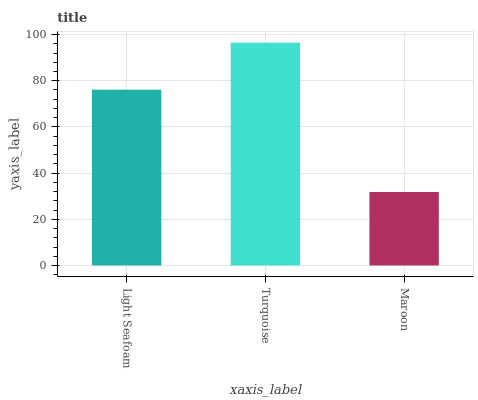Is Maroon the minimum?
Answer yes or no. Yes. Is Turquoise the maximum?
Answer yes or no. Yes. Is Turquoise the minimum?
Answer yes or no. No. Is Maroon the maximum?
Answer yes or no. No. Is Turquoise greater than Maroon?
Answer yes or no. Yes. Is Maroon less than Turquoise?
Answer yes or no. Yes. Is Maroon greater than Turquoise?
Answer yes or no. No. Is Turquoise less than Maroon?
Answer yes or no. No. Is Light Seafoam the high median?
Answer yes or no. Yes. Is Light Seafoam the low median?
Answer yes or no. Yes. Is Maroon the high median?
Answer yes or no. No. Is Maroon the low median?
Answer yes or no. No. 